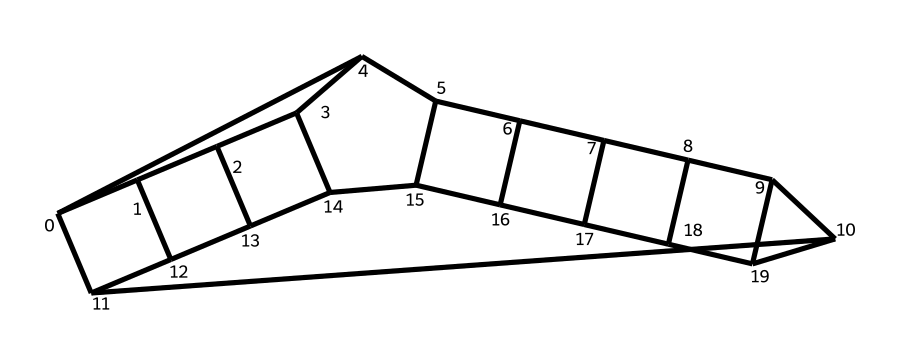How many carbon atoms are in dodecahedrane? By examining the overall structure represented in the SMILES notation, we can count the number of carbon atoms present. The structure indicates 12 carbon atoms arranged in a cage-like formation.
Answer: twelve What type of bonding is primarily present in dodecahedrane? Analyzing the structure, we see that it contains only carbon-carbon bonds and carbon-hydrogen bonds, which are typical for hydrocarbons. Therefore, the primary bonding type in this molecule is covalent.
Answer: covalent Is dodecahedrane symmetrical? Observing the molecular framework exhibited in the structure, it displays a high degree of symmetry, characteristic of cage compounds. Therefore, we can conclude that it is symmetrical.
Answer: yes What is the significance of dodecahedrane in advanced materials? Dodecahedrane is used in advanced materials for children's toys due to its unique structural properties, including its strength and light weight, which enhance safety and durability.
Answer: unique structural properties How many vertices does the cage structure of dodecahedrane have? The arrangement of the carbon atoms in the dodecahedrane structure forms a polyhedral shape with a total of 12 vertices, corresponding to the 12 carbon atoms.
Answer: twelve What distinguishes dodecahedrane from other hydrocarbons? Dodecahedrane's unique cage-like structure and its specific arrangement of carbon atoms set it apart from linear or branched hydrocarbons, allowing it to exhibit distinctive physical properties.
Answer: cage-like structure 